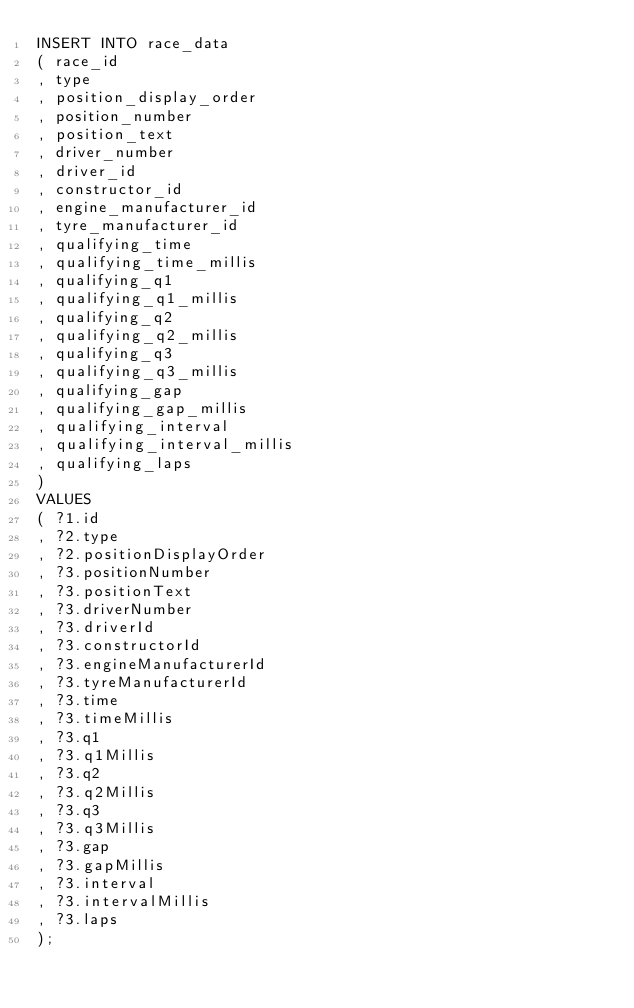<code> <loc_0><loc_0><loc_500><loc_500><_SQL_>INSERT INTO race_data
( race_id
, type
, position_display_order
, position_number
, position_text
, driver_number
, driver_id
, constructor_id
, engine_manufacturer_id
, tyre_manufacturer_id
, qualifying_time
, qualifying_time_millis
, qualifying_q1
, qualifying_q1_millis
, qualifying_q2
, qualifying_q2_millis
, qualifying_q3
, qualifying_q3_millis
, qualifying_gap
, qualifying_gap_millis
, qualifying_interval
, qualifying_interval_millis
, qualifying_laps
)
VALUES
( ?1.id
, ?2.type
, ?2.positionDisplayOrder
, ?3.positionNumber
, ?3.positionText
, ?3.driverNumber
, ?3.driverId
, ?3.constructorId
, ?3.engineManufacturerId
, ?3.tyreManufacturerId
, ?3.time
, ?3.timeMillis
, ?3.q1
, ?3.q1Millis
, ?3.q2
, ?3.q2Millis
, ?3.q3
, ?3.q3Millis
, ?3.gap
, ?3.gapMillis
, ?3.interval
, ?3.intervalMillis
, ?3.laps
);
</code> 